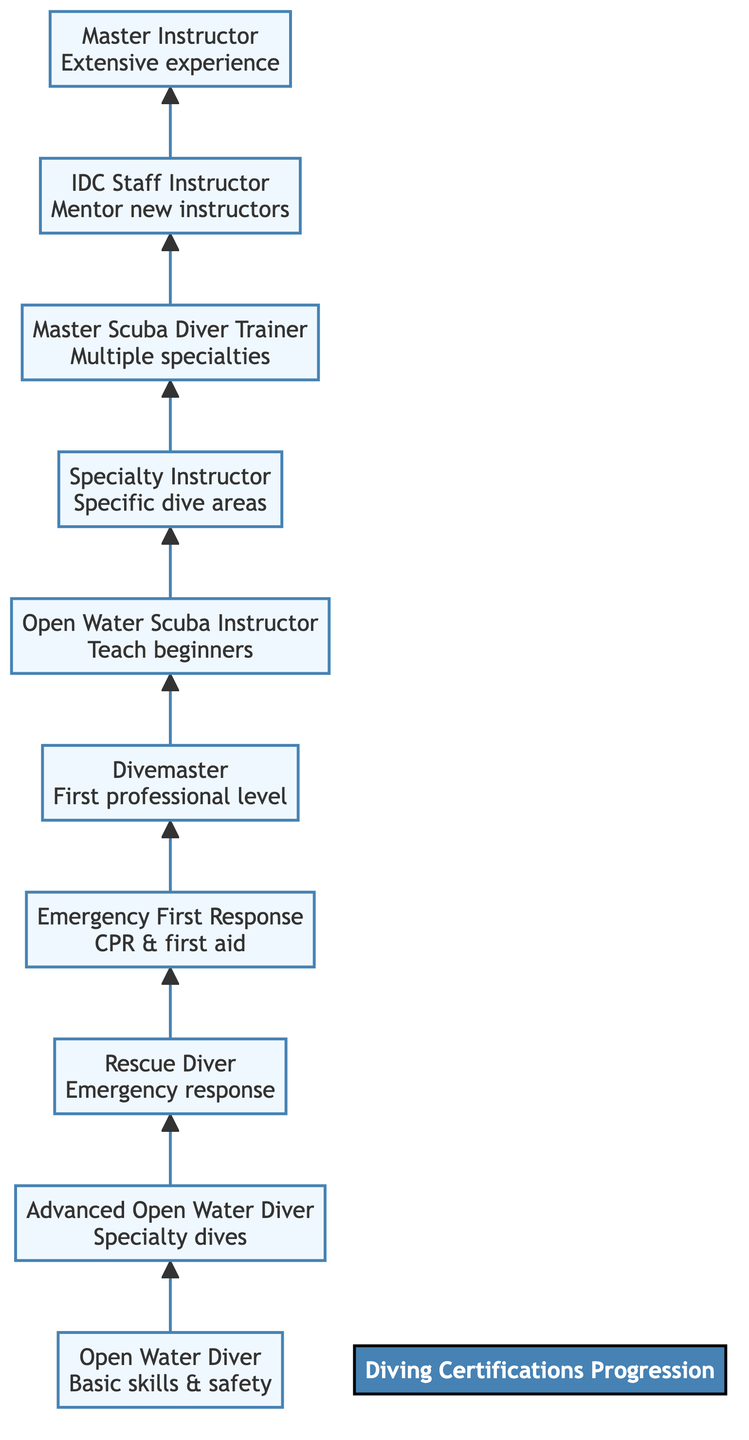What is the first certification in the progression? The diagram shows that the first certification at the bottom of the flow chart is "Open Water Diver," which is the entry-level certification for divers.
Answer: Open Water Diver How many levels of certifications are there? By counting the nodes in the flow chart, there are 10 distinct levels of certifications mentioned from Open Water Diver to Master Instructor.
Answer: 10 What follows "Divemaster" in the certification progression? The flow chart indicates that "Open Water Scuba Instructor" comes directly after "Divemaster," continuing the certification progression upward.
Answer: Open Water Scuba Instructor Which certification focuses on emergency response techniques? The diagram highlights that "Rescue Diver" is the certification specifically aimed at enhancing emergency response and rescue techniques for divers.
Answer: Rescue Diver What is the highest level of certification shown? The topmost certification in the flow chart is "Master Instructor," indicating it is the highest level of achievement in this progression.
Answer: Master Instructor Which certification prepares instructors to teach beginner courses? According to the flow chart, "Open Water Scuba Instructor" is the certification that enables individuals to teach beginner diving courses.
Answer: Open Water Scuba Instructor What certification is required before obtaining the Master Instructor certification? The flow chart illustrates that "IDC Staff Instructor" is the prerequisite certification immediately before achieving the Master Instructor level.
Answer: IDC Staff Instructor Which level involves assisting Course Directors? The diagram specifies that the "IDC Staff Instructor" level includes responsibilities like assisting Course Directors in teaching Instructor Development Courses.
Answer: IDC Staff Instructor How does one progress from "Advanced Open Water Diver" to "Rescue Diver"? The diagram shows a direct upward flow from "Advanced Open Water Diver" to "Rescue Diver," indicating a sequential progression in certifications.
Answer: Rescue Diver 